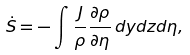<formula> <loc_0><loc_0><loc_500><loc_500>\dot { S } = - \int \frac { J } { \rho } \frac { \partial \rho } { \partial \eta } \, d y d z d \eta ,</formula> 